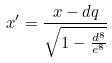<formula> <loc_0><loc_0><loc_500><loc_500>x ^ { \prime } = \frac { x - d q } { \sqrt { 1 - \frac { d ^ { 8 } } { e ^ { 8 } } } }</formula> 